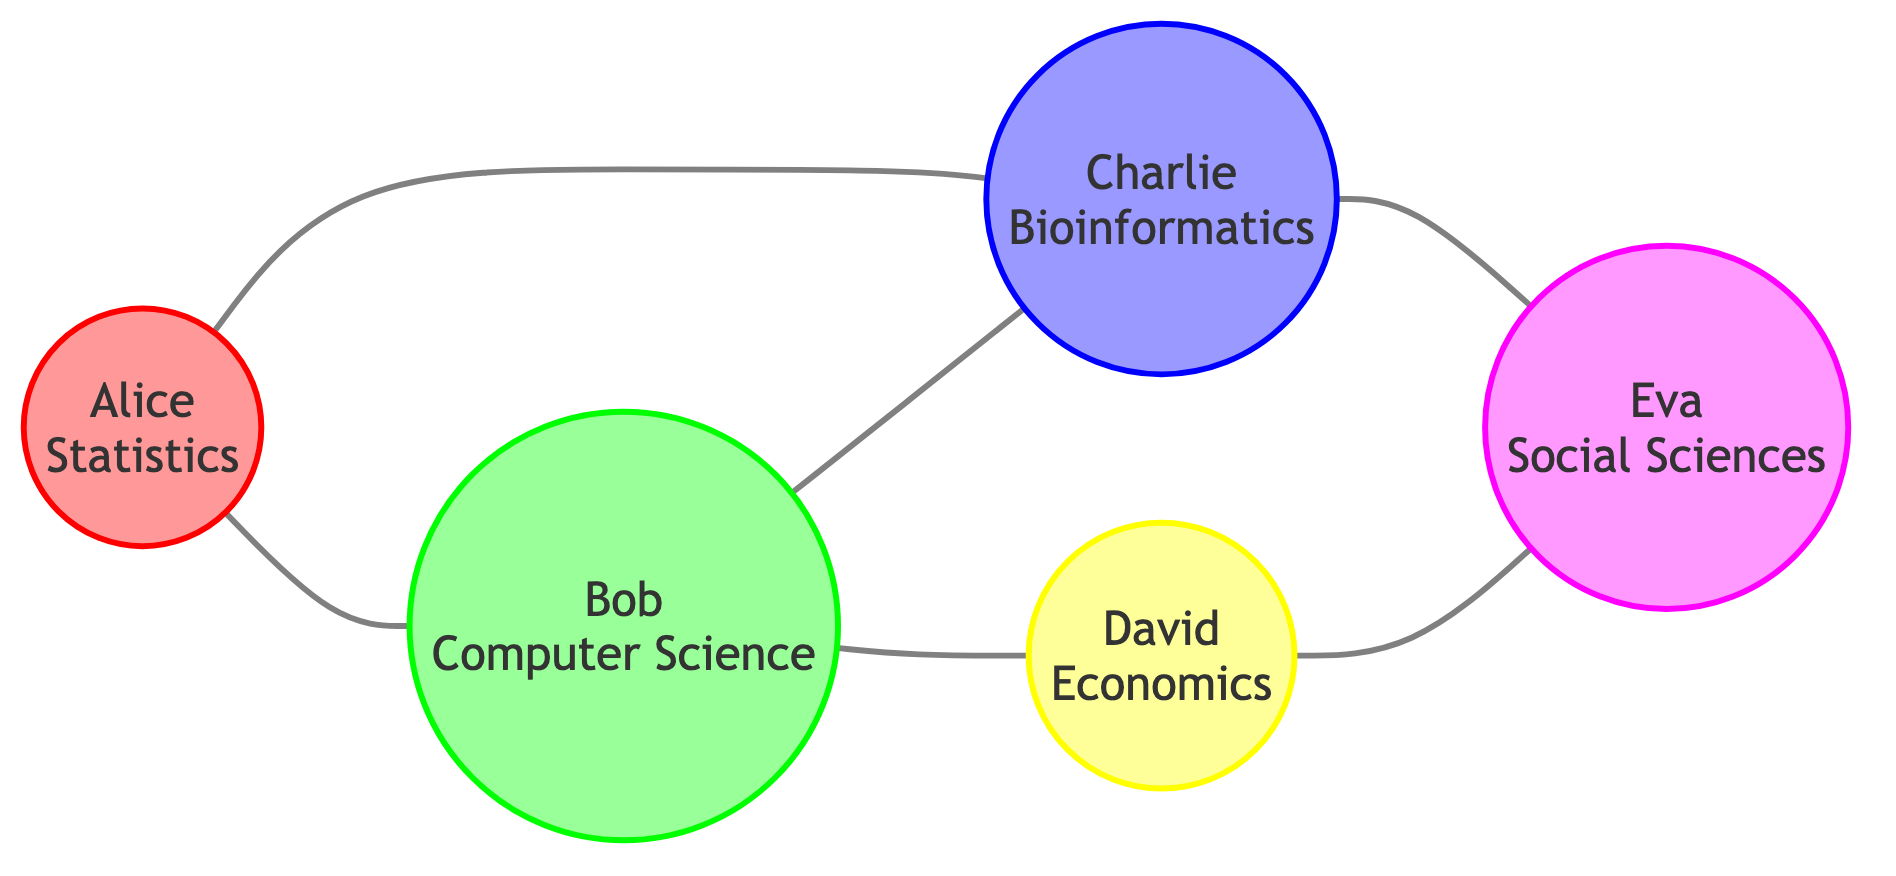What is the total number of nodes in the graph? The graph consists of five different individuals identified as nodes, which are Alice, Bob, Charlie, David, and Eva. Therefore, the total number of nodes is counted directly from the diagram.
Answer: 5 Which publications connect Alice and Charlie? The direct connection between Alice and Charlie is through the "Bioinformatics Journal." This edge is explicitly listed in the edges section of the data provided.
Answer: Bioinformatics Journal How many edges are there in total? By counting all connections (edges) between nodes, there are six distinct relationships described in the edges section of the data: Alice to Bob, Alice to Charlie, Bob to Charlie, Bob to David, Charlie to Eva, and David to Eva.
Answer: 6 Which field is connected to Eva through Charlie? The edge connecting Charlie and Eva indicates that Charlie, who is in the Bioinformatics field, has a publication relationship with Eva. Thus, the answer to which field connects to Eva through Charlie is Bioinformatics.
Answer: Bioinformatics What is the relationship between Bob and David? The direct edge between Bob and David indicates that they have collaborated on the publication titled "Econometrics and Statistics." This relationship is shown in the edges of the diagram.
Answer: Econometrics and Statistics Which discipline has the most connections in the graph? By analyzing the edges, Bob, from Computer Science, has connections to four individuals (Alice, Charlie, and David) compared to others. Thus, Computer Science is the discipline with the most connections.
Answer: Computer Science How many unique disciplines are represented in the graph? The disciplines represented in the nodes are Statistics (Alice), Computer Science (Bob), Bioinformatics (Charlie), Economics (David), and Social Sciences (Eva). Therefore, there are five unique disciplines in total.
Answer: 5 Which author collaborates with both Charlie and Eva? By tracing connections from Charlie to Eva in the diagram, we can see that the only common collaborator connected to both is Charlie, who collaborates with Eva directly, while Charlie collaborates indirectly with the others.
Answer: Charlie What is the shortest path from Alice to Eva? The path from Alice to Eva can be traced as follows: Alice to Bob (edge), Bob to Charlie (edge), and Charlie to Eva (edge). This creates a three-step path from Alice to Eva.
Answer: 3 